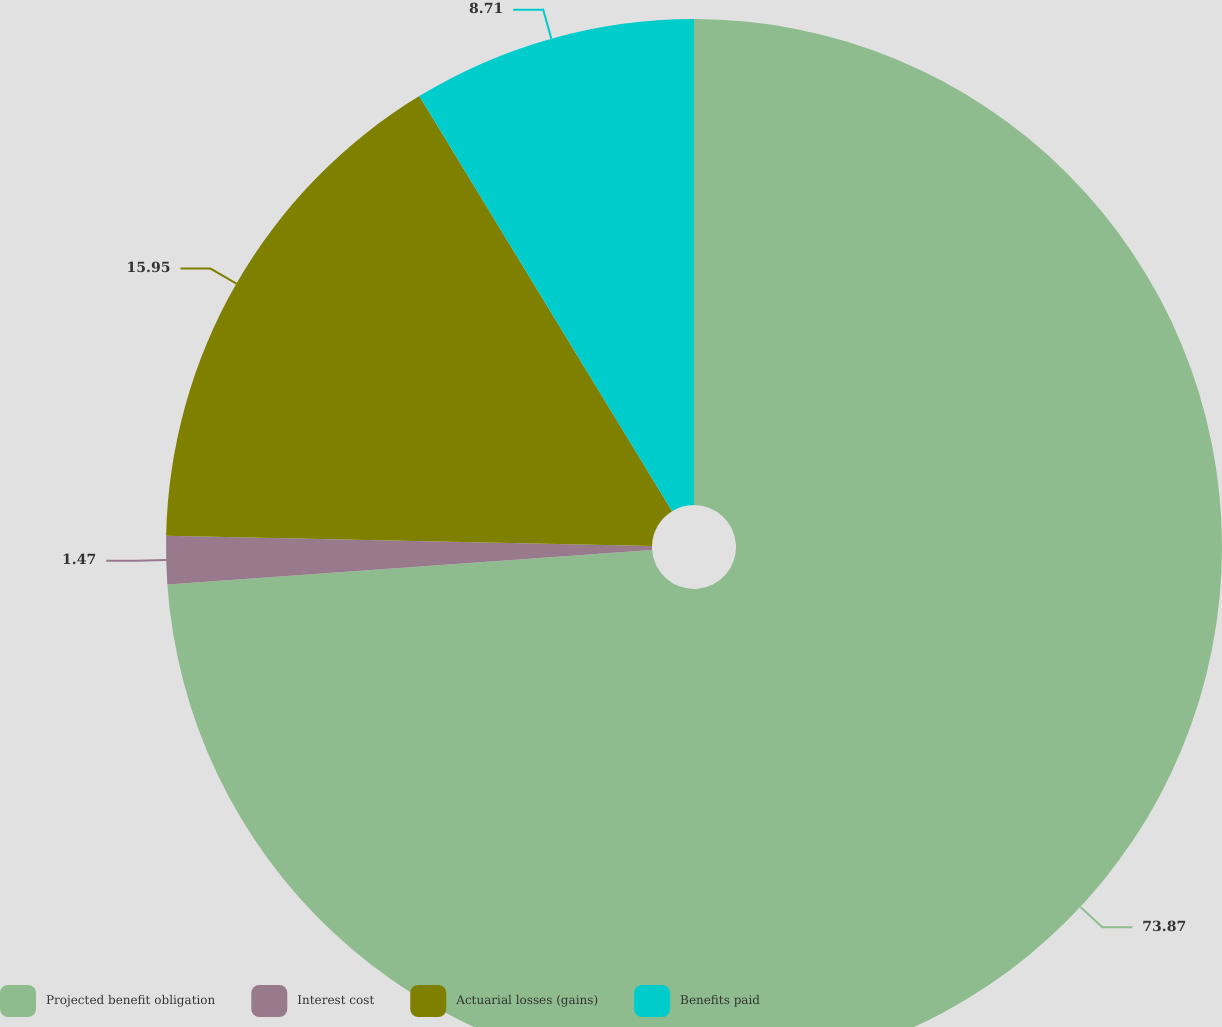<chart> <loc_0><loc_0><loc_500><loc_500><pie_chart><fcel>Projected benefit obligation<fcel>Interest cost<fcel>Actuarial losses (gains)<fcel>Benefits paid<nl><fcel>73.87%<fcel>1.47%<fcel>15.95%<fcel>8.71%<nl></chart> 